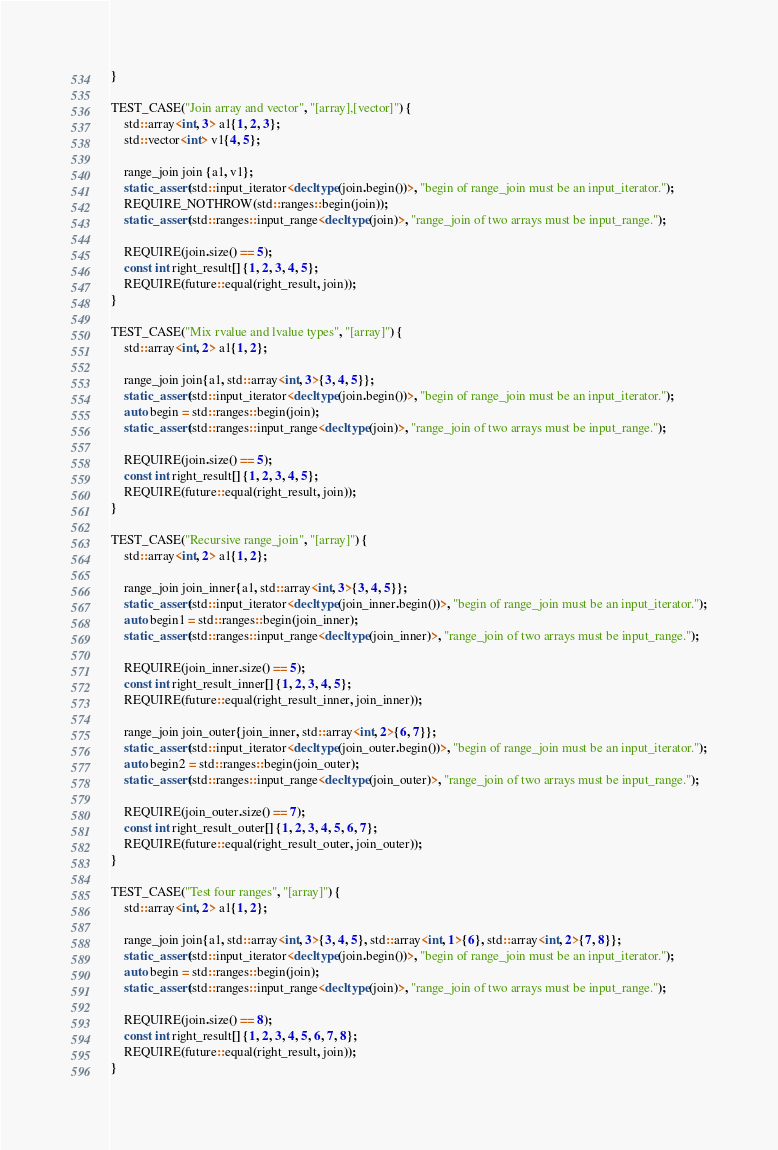Convert code to text. <code><loc_0><loc_0><loc_500><loc_500><_C++_>}

TEST_CASE("Join array and vector", "[array],[vector]") {
    std::array<int, 3> a1{1, 2, 3};
    std::vector<int> v1{4, 5};

    range_join join {a1, v1};
    static_assert(std::input_iterator<decltype(join.begin())>, "begin of range_join must be an input_iterator.");
    REQUIRE_NOTHROW(std::ranges::begin(join));
    static_assert(std::ranges::input_range<decltype(join)>, "range_join of two arrays must be input_range.");

    REQUIRE(join.size() == 5);
    const int right_result[] {1, 2, 3, 4, 5};
    REQUIRE(future::equal(right_result, join));
}

TEST_CASE("Mix rvalue and lvalue types", "[array]") {
    std::array<int, 2> a1{1, 2};

    range_join join{a1, std::array<int, 3>{3, 4, 5}};
    static_assert(std::input_iterator<decltype(join.begin())>, "begin of range_join must be an input_iterator.");
    auto begin = std::ranges::begin(join);
    static_assert(std::ranges::input_range<decltype(join)>, "range_join of two arrays must be input_range.");

    REQUIRE(join.size() == 5);
    const int right_result[] {1, 2, 3, 4, 5};
    REQUIRE(future::equal(right_result, join));
}

TEST_CASE("Recursive range_join", "[array]") {
    std::array<int, 2> a1{1, 2};

    range_join join_inner{a1, std::array<int, 3>{3, 4, 5}};
    static_assert(std::input_iterator<decltype(join_inner.begin())>, "begin of range_join must be an input_iterator.");
    auto begin1 = std::ranges::begin(join_inner);
    static_assert(std::ranges::input_range<decltype(join_inner)>, "range_join of two arrays must be input_range.");

    REQUIRE(join_inner.size() == 5);
    const int right_result_inner[] {1, 2, 3, 4, 5};
    REQUIRE(future::equal(right_result_inner, join_inner));

    range_join join_outer{join_inner, std::array<int, 2>{6, 7}};
    static_assert(std::input_iterator<decltype(join_outer.begin())>, "begin of range_join must be an input_iterator.");
    auto begin2 = std::ranges::begin(join_outer);
    static_assert(std::ranges::input_range<decltype(join_outer)>, "range_join of two arrays must be input_range.");

    REQUIRE(join_outer.size() == 7);
    const int right_result_outer[] {1, 2, 3, 4, 5, 6, 7};
    REQUIRE(future::equal(right_result_outer, join_outer));
}

TEST_CASE("Test four ranges", "[array]") {
    std::array<int, 2> a1{1, 2};

    range_join join{a1, std::array<int, 3>{3, 4, 5}, std::array<int, 1>{6}, std::array<int, 2>{7, 8}};
    static_assert(std::input_iterator<decltype(join.begin())>, "begin of range_join must be an input_iterator.");
    auto begin = std::ranges::begin(join);
    static_assert(std::ranges::input_range<decltype(join)>, "range_join of two arrays must be input_range.");

    REQUIRE(join.size() == 8);
    const int right_result[] {1, 2, 3, 4, 5, 6, 7, 8};
    REQUIRE(future::equal(right_result, join));
}
</code> 